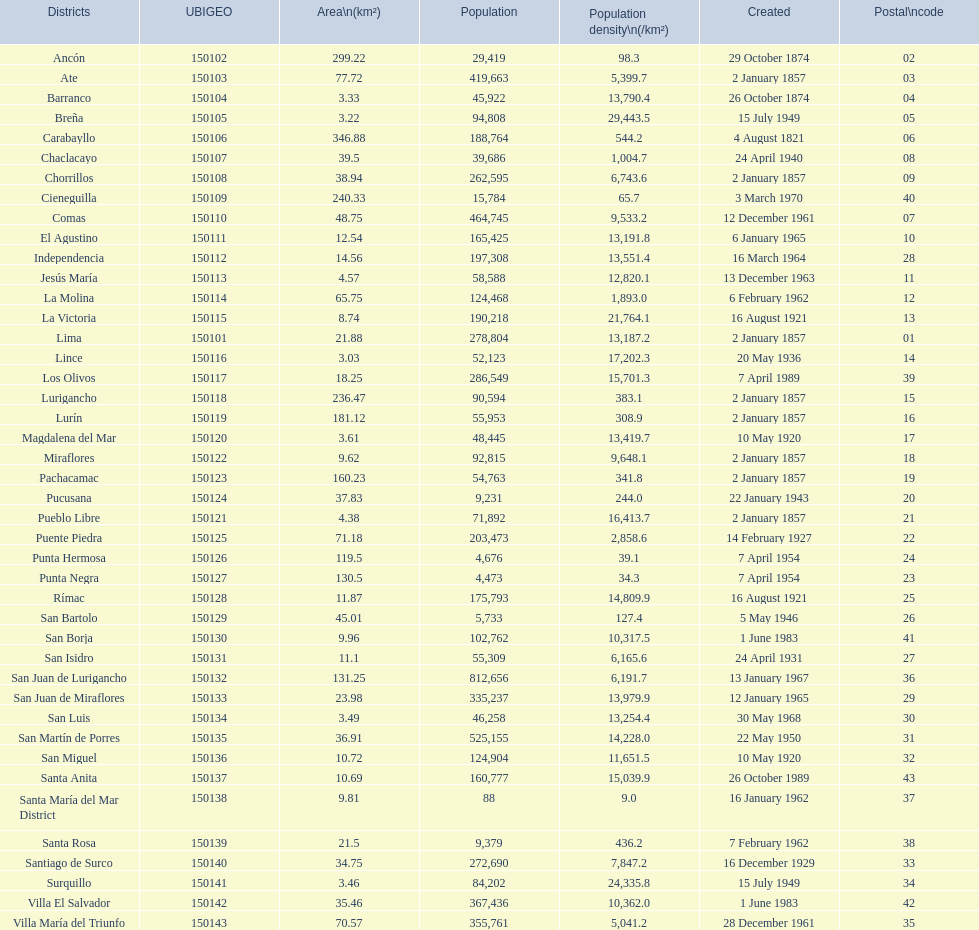What is the overall count of districts established in the 1900's? 32. 